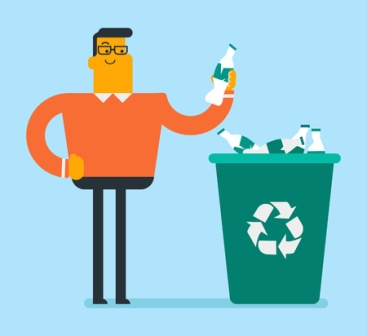What's happening in the scene? In the image, a man with glasses is prominently featured, dressed in an orange sweater and black pants. He is holding a green bottle in his right hand, which appears to be the sharegpt4v/same kind of bottle filling the green recycling bin beside him. The recycling bin is marked with the universal recycling symbol and is filled with several white bottles. This setup, against a light blue background, suggests that the man is actively participating in recycling. The image conveys an important message about environmental consciousness and the value of recycling, urging viewers to take similar actions in their own lives. 